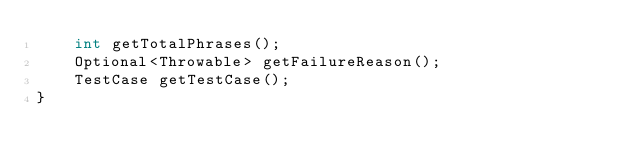Convert code to text. <code><loc_0><loc_0><loc_500><loc_500><_Java_>    int getTotalPhrases();
    Optional<Throwable> getFailureReason();
    TestCase getTestCase();
}
</code> 